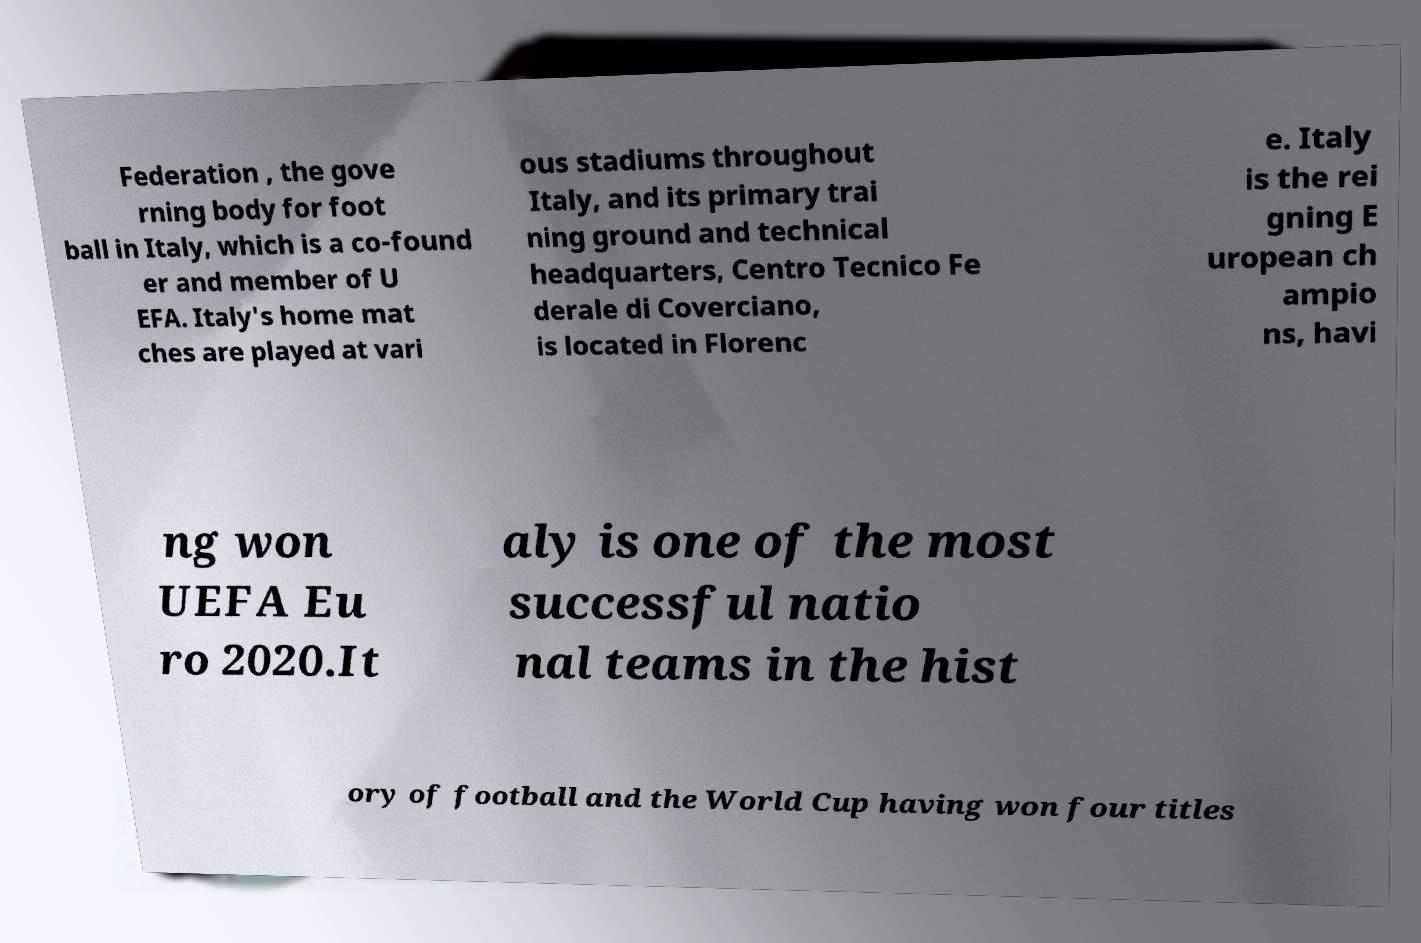For documentation purposes, I need the text within this image transcribed. Could you provide that? Federation , the gove rning body for foot ball in Italy, which is a co-found er and member of U EFA. Italy's home mat ches are played at vari ous stadiums throughout Italy, and its primary trai ning ground and technical headquarters, Centro Tecnico Fe derale di Coverciano, is located in Florenc e. Italy is the rei gning E uropean ch ampio ns, havi ng won UEFA Eu ro 2020.It aly is one of the most successful natio nal teams in the hist ory of football and the World Cup having won four titles 